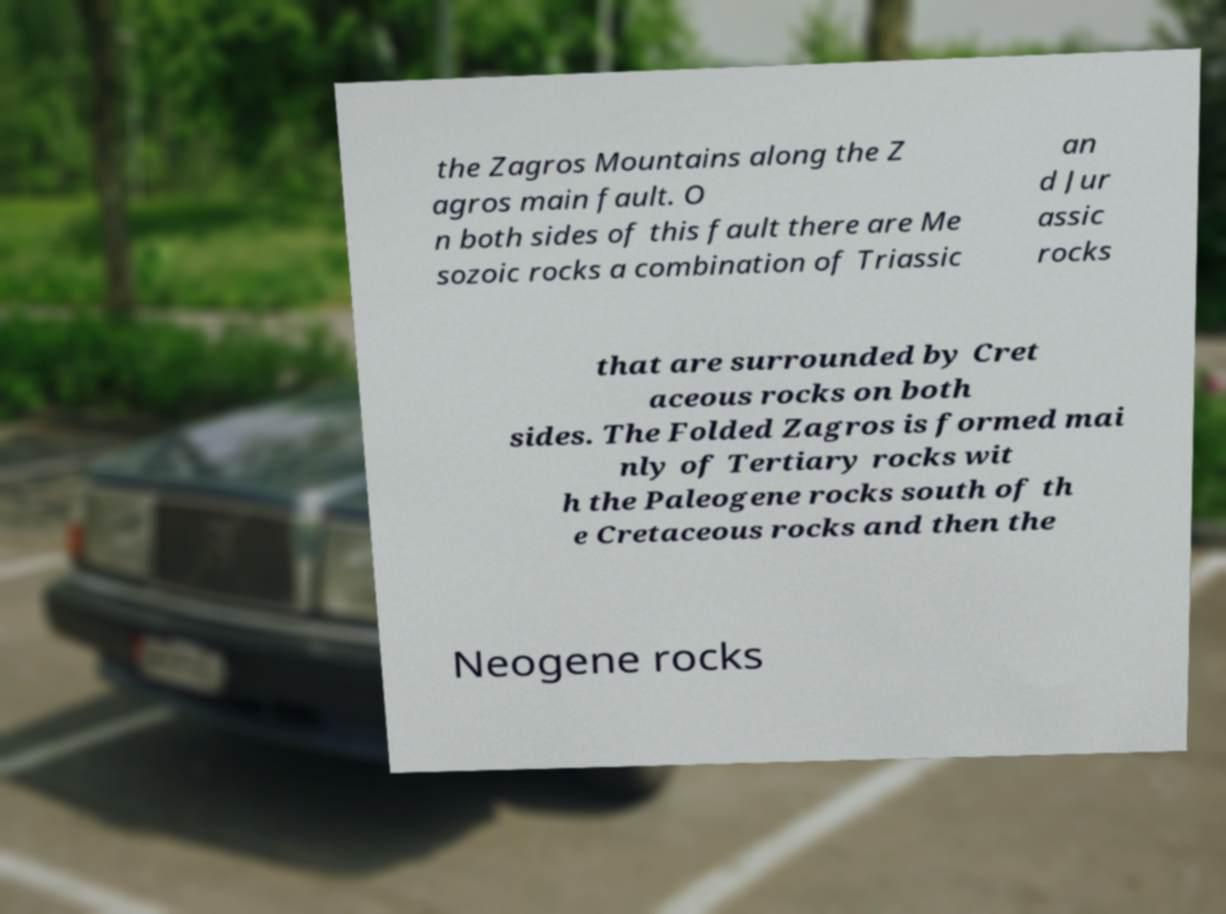Could you extract and type out the text from this image? the Zagros Mountains along the Z agros main fault. O n both sides of this fault there are Me sozoic rocks a combination of Triassic an d Jur assic rocks that are surrounded by Cret aceous rocks on both sides. The Folded Zagros is formed mai nly of Tertiary rocks wit h the Paleogene rocks south of th e Cretaceous rocks and then the Neogene rocks 